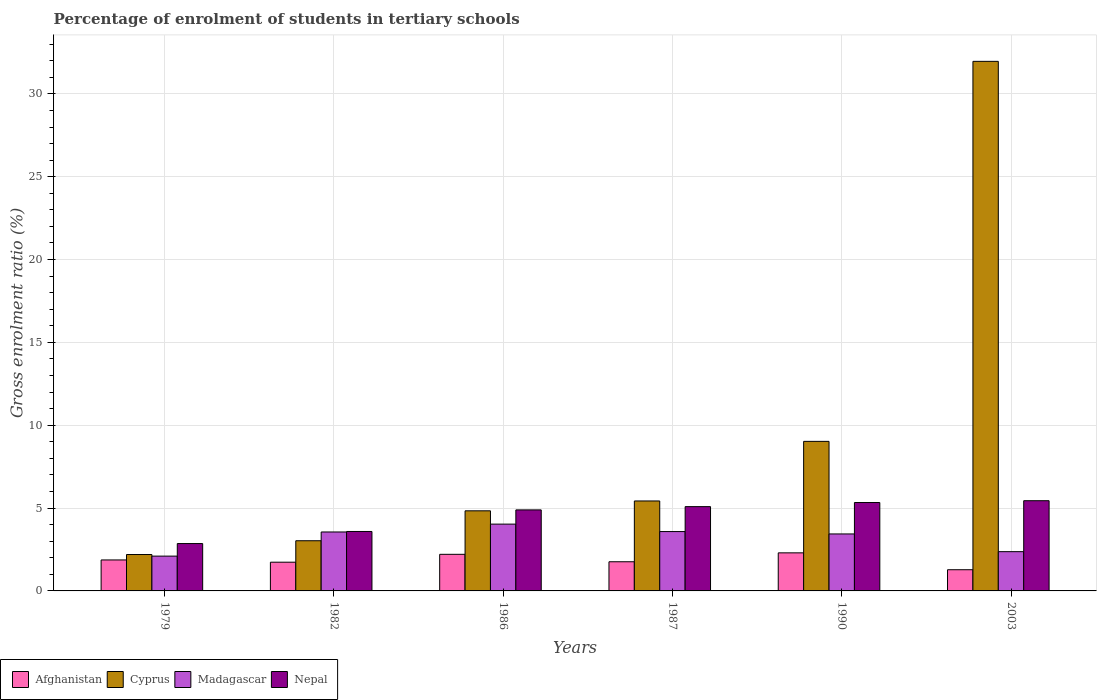How many different coloured bars are there?
Your answer should be very brief. 4. Are the number of bars per tick equal to the number of legend labels?
Your answer should be very brief. Yes. How many bars are there on the 5th tick from the right?
Keep it short and to the point. 4. What is the label of the 3rd group of bars from the left?
Give a very brief answer. 1986. In how many cases, is the number of bars for a given year not equal to the number of legend labels?
Provide a short and direct response. 0. What is the percentage of students enrolled in tertiary schools in Afghanistan in 1990?
Ensure brevity in your answer.  2.3. Across all years, what is the maximum percentage of students enrolled in tertiary schools in Madagascar?
Offer a terse response. 4.03. Across all years, what is the minimum percentage of students enrolled in tertiary schools in Cyprus?
Offer a very short reply. 2.2. In which year was the percentage of students enrolled in tertiary schools in Nepal maximum?
Provide a succinct answer. 2003. In which year was the percentage of students enrolled in tertiary schools in Nepal minimum?
Your answer should be compact. 1979. What is the total percentage of students enrolled in tertiary schools in Cyprus in the graph?
Make the answer very short. 56.48. What is the difference between the percentage of students enrolled in tertiary schools in Nepal in 1979 and that in 1987?
Your response must be concise. -2.23. What is the difference between the percentage of students enrolled in tertiary schools in Madagascar in 1986 and the percentage of students enrolled in tertiary schools in Afghanistan in 1982?
Give a very brief answer. 2.3. What is the average percentage of students enrolled in tertiary schools in Cyprus per year?
Offer a terse response. 9.41. In the year 1982, what is the difference between the percentage of students enrolled in tertiary schools in Afghanistan and percentage of students enrolled in tertiary schools in Cyprus?
Offer a terse response. -1.3. In how many years, is the percentage of students enrolled in tertiary schools in Nepal greater than 3 %?
Offer a very short reply. 5. What is the ratio of the percentage of students enrolled in tertiary schools in Madagascar in 1979 to that in 1982?
Offer a terse response. 0.59. Is the percentage of students enrolled in tertiary schools in Madagascar in 1986 less than that in 1987?
Provide a short and direct response. No. Is the difference between the percentage of students enrolled in tertiary schools in Afghanistan in 1990 and 2003 greater than the difference between the percentage of students enrolled in tertiary schools in Cyprus in 1990 and 2003?
Your answer should be very brief. Yes. What is the difference between the highest and the second highest percentage of students enrolled in tertiary schools in Afghanistan?
Provide a short and direct response. 0.09. What is the difference between the highest and the lowest percentage of students enrolled in tertiary schools in Afghanistan?
Keep it short and to the point. 1.02. In how many years, is the percentage of students enrolled in tertiary schools in Cyprus greater than the average percentage of students enrolled in tertiary schools in Cyprus taken over all years?
Your answer should be very brief. 1. What does the 1st bar from the left in 2003 represents?
Your response must be concise. Afghanistan. What does the 1st bar from the right in 1986 represents?
Provide a succinct answer. Nepal. Is it the case that in every year, the sum of the percentage of students enrolled in tertiary schools in Nepal and percentage of students enrolled in tertiary schools in Madagascar is greater than the percentage of students enrolled in tertiary schools in Cyprus?
Provide a short and direct response. No. Are all the bars in the graph horizontal?
Your response must be concise. No. How many years are there in the graph?
Ensure brevity in your answer.  6. What is the difference between two consecutive major ticks on the Y-axis?
Your response must be concise. 5. Does the graph contain grids?
Offer a very short reply. Yes. Where does the legend appear in the graph?
Your response must be concise. Bottom left. How many legend labels are there?
Provide a short and direct response. 4. How are the legend labels stacked?
Provide a short and direct response. Horizontal. What is the title of the graph?
Give a very brief answer. Percentage of enrolment of students in tertiary schools. Does "Uganda" appear as one of the legend labels in the graph?
Offer a terse response. No. What is the label or title of the X-axis?
Your answer should be very brief. Years. What is the label or title of the Y-axis?
Your answer should be very brief. Gross enrolment ratio (%). What is the Gross enrolment ratio (%) in Afghanistan in 1979?
Offer a terse response. 1.87. What is the Gross enrolment ratio (%) of Cyprus in 1979?
Offer a terse response. 2.2. What is the Gross enrolment ratio (%) of Madagascar in 1979?
Your answer should be compact. 2.1. What is the Gross enrolment ratio (%) in Nepal in 1979?
Your answer should be very brief. 2.86. What is the Gross enrolment ratio (%) in Afghanistan in 1982?
Ensure brevity in your answer.  1.73. What is the Gross enrolment ratio (%) of Cyprus in 1982?
Make the answer very short. 3.03. What is the Gross enrolment ratio (%) of Madagascar in 1982?
Offer a very short reply. 3.56. What is the Gross enrolment ratio (%) in Nepal in 1982?
Offer a very short reply. 3.59. What is the Gross enrolment ratio (%) of Afghanistan in 1986?
Provide a succinct answer. 2.21. What is the Gross enrolment ratio (%) in Cyprus in 1986?
Your answer should be very brief. 4.83. What is the Gross enrolment ratio (%) in Madagascar in 1986?
Your answer should be very brief. 4.03. What is the Gross enrolment ratio (%) of Nepal in 1986?
Your response must be concise. 4.89. What is the Gross enrolment ratio (%) in Afghanistan in 1987?
Ensure brevity in your answer.  1.76. What is the Gross enrolment ratio (%) of Cyprus in 1987?
Your answer should be compact. 5.43. What is the Gross enrolment ratio (%) in Madagascar in 1987?
Offer a very short reply. 3.58. What is the Gross enrolment ratio (%) of Nepal in 1987?
Your answer should be very brief. 5.09. What is the Gross enrolment ratio (%) in Afghanistan in 1990?
Make the answer very short. 2.3. What is the Gross enrolment ratio (%) of Cyprus in 1990?
Offer a terse response. 9.03. What is the Gross enrolment ratio (%) of Madagascar in 1990?
Provide a short and direct response. 3.44. What is the Gross enrolment ratio (%) in Nepal in 1990?
Make the answer very short. 5.34. What is the Gross enrolment ratio (%) of Afghanistan in 2003?
Provide a succinct answer. 1.28. What is the Gross enrolment ratio (%) of Cyprus in 2003?
Ensure brevity in your answer.  31.96. What is the Gross enrolment ratio (%) of Madagascar in 2003?
Provide a succinct answer. 2.37. What is the Gross enrolment ratio (%) in Nepal in 2003?
Provide a short and direct response. 5.44. Across all years, what is the maximum Gross enrolment ratio (%) of Afghanistan?
Your answer should be very brief. 2.3. Across all years, what is the maximum Gross enrolment ratio (%) in Cyprus?
Offer a terse response. 31.96. Across all years, what is the maximum Gross enrolment ratio (%) in Madagascar?
Your response must be concise. 4.03. Across all years, what is the maximum Gross enrolment ratio (%) in Nepal?
Your answer should be compact. 5.44. Across all years, what is the minimum Gross enrolment ratio (%) in Afghanistan?
Keep it short and to the point. 1.28. Across all years, what is the minimum Gross enrolment ratio (%) of Cyprus?
Make the answer very short. 2.2. Across all years, what is the minimum Gross enrolment ratio (%) in Madagascar?
Offer a terse response. 2.1. Across all years, what is the minimum Gross enrolment ratio (%) in Nepal?
Offer a very short reply. 2.86. What is the total Gross enrolment ratio (%) in Afghanistan in the graph?
Make the answer very short. 11.15. What is the total Gross enrolment ratio (%) in Cyprus in the graph?
Make the answer very short. 56.48. What is the total Gross enrolment ratio (%) of Madagascar in the graph?
Provide a short and direct response. 19.08. What is the total Gross enrolment ratio (%) in Nepal in the graph?
Offer a very short reply. 27.21. What is the difference between the Gross enrolment ratio (%) in Afghanistan in 1979 and that in 1982?
Offer a very short reply. 0.14. What is the difference between the Gross enrolment ratio (%) of Cyprus in 1979 and that in 1982?
Your answer should be very brief. -0.83. What is the difference between the Gross enrolment ratio (%) in Madagascar in 1979 and that in 1982?
Offer a terse response. -1.46. What is the difference between the Gross enrolment ratio (%) of Nepal in 1979 and that in 1982?
Offer a terse response. -0.73. What is the difference between the Gross enrolment ratio (%) of Afghanistan in 1979 and that in 1986?
Your answer should be very brief. -0.34. What is the difference between the Gross enrolment ratio (%) in Cyprus in 1979 and that in 1986?
Make the answer very short. -2.64. What is the difference between the Gross enrolment ratio (%) of Madagascar in 1979 and that in 1986?
Make the answer very short. -1.93. What is the difference between the Gross enrolment ratio (%) of Nepal in 1979 and that in 1986?
Your response must be concise. -2.03. What is the difference between the Gross enrolment ratio (%) in Afghanistan in 1979 and that in 1987?
Your answer should be compact. 0.11. What is the difference between the Gross enrolment ratio (%) of Cyprus in 1979 and that in 1987?
Provide a succinct answer. -3.23. What is the difference between the Gross enrolment ratio (%) of Madagascar in 1979 and that in 1987?
Provide a short and direct response. -1.48. What is the difference between the Gross enrolment ratio (%) of Nepal in 1979 and that in 1987?
Your answer should be very brief. -2.23. What is the difference between the Gross enrolment ratio (%) of Afghanistan in 1979 and that in 1990?
Your answer should be compact. -0.43. What is the difference between the Gross enrolment ratio (%) in Cyprus in 1979 and that in 1990?
Provide a short and direct response. -6.83. What is the difference between the Gross enrolment ratio (%) of Madagascar in 1979 and that in 1990?
Ensure brevity in your answer.  -1.34. What is the difference between the Gross enrolment ratio (%) of Nepal in 1979 and that in 1990?
Offer a terse response. -2.48. What is the difference between the Gross enrolment ratio (%) of Afghanistan in 1979 and that in 2003?
Offer a terse response. 0.59. What is the difference between the Gross enrolment ratio (%) of Cyprus in 1979 and that in 2003?
Keep it short and to the point. -29.77. What is the difference between the Gross enrolment ratio (%) in Madagascar in 1979 and that in 2003?
Give a very brief answer. -0.27. What is the difference between the Gross enrolment ratio (%) in Nepal in 1979 and that in 2003?
Keep it short and to the point. -2.59. What is the difference between the Gross enrolment ratio (%) in Afghanistan in 1982 and that in 1986?
Keep it short and to the point. -0.47. What is the difference between the Gross enrolment ratio (%) in Cyprus in 1982 and that in 1986?
Provide a succinct answer. -1.81. What is the difference between the Gross enrolment ratio (%) of Madagascar in 1982 and that in 1986?
Make the answer very short. -0.47. What is the difference between the Gross enrolment ratio (%) of Nepal in 1982 and that in 1986?
Offer a terse response. -1.3. What is the difference between the Gross enrolment ratio (%) of Afghanistan in 1982 and that in 1987?
Your response must be concise. -0.03. What is the difference between the Gross enrolment ratio (%) in Cyprus in 1982 and that in 1987?
Keep it short and to the point. -2.4. What is the difference between the Gross enrolment ratio (%) in Madagascar in 1982 and that in 1987?
Ensure brevity in your answer.  -0.02. What is the difference between the Gross enrolment ratio (%) of Nepal in 1982 and that in 1987?
Provide a succinct answer. -1.5. What is the difference between the Gross enrolment ratio (%) of Afghanistan in 1982 and that in 1990?
Make the answer very short. -0.56. What is the difference between the Gross enrolment ratio (%) of Cyprus in 1982 and that in 1990?
Your answer should be very brief. -6. What is the difference between the Gross enrolment ratio (%) of Madagascar in 1982 and that in 1990?
Keep it short and to the point. 0.12. What is the difference between the Gross enrolment ratio (%) of Nepal in 1982 and that in 1990?
Offer a terse response. -1.75. What is the difference between the Gross enrolment ratio (%) of Afghanistan in 1982 and that in 2003?
Provide a short and direct response. 0.45. What is the difference between the Gross enrolment ratio (%) in Cyprus in 1982 and that in 2003?
Your answer should be very brief. -28.93. What is the difference between the Gross enrolment ratio (%) in Madagascar in 1982 and that in 2003?
Offer a terse response. 1.19. What is the difference between the Gross enrolment ratio (%) in Nepal in 1982 and that in 2003?
Keep it short and to the point. -1.86. What is the difference between the Gross enrolment ratio (%) in Afghanistan in 1986 and that in 1987?
Give a very brief answer. 0.45. What is the difference between the Gross enrolment ratio (%) of Cyprus in 1986 and that in 1987?
Your answer should be very brief. -0.59. What is the difference between the Gross enrolment ratio (%) of Madagascar in 1986 and that in 1987?
Offer a terse response. 0.45. What is the difference between the Gross enrolment ratio (%) of Nepal in 1986 and that in 1987?
Your answer should be very brief. -0.2. What is the difference between the Gross enrolment ratio (%) of Afghanistan in 1986 and that in 1990?
Give a very brief answer. -0.09. What is the difference between the Gross enrolment ratio (%) in Cyprus in 1986 and that in 1990?
Provide a succinct answer. -4.19. What is the difference between the Gross enrolment ratio (%) of Madagascar in 1986 and that in 1990?
Your answer should be compact. 0.59. What is the difference between the Gross enrolment ratio (%) of Nepal in 1986 and that in 1990?
Keep it short and to the point. -0.44. What is the difference between the Gross enrolment ratio (%) of Afghanistan in 1986 and that in 2003?
Your answer should be very brief. 0.93. What is the difference between the Gross enrolment ratio (%) of Cyprus in 1986 and that in 2003?
Ensure brevity in your answer.  -27.13. What is the difference between the Gross enrolment ratio (%) of Madagascar in 1986 and that in 2003?
Give a very brief answer. 1.66. What is the difference between the Gross enrolment ratio (%) in Nepal in 1986 and that in 2003?
Offer a terse response. -0.55. What is the difference between the Gross enrolment ratio (%) in Afghanistan in 1987 and that in 1990?
Provide a succinct answer. -0.54. What is the difference between the Gross enrolment ratio (%) of Cyprus in 1987 and that in 1990?
Your response must be concise. -3.6. What is the difference between the Gross enrolment ratio (%) in Madagascar in 1987 and that in 1990?
Ensure brevity in your answer.  0.14. What is the difference between the Gross enrolment ratio (%) of Nepal in 1987 and that in 1990?
Offer a very short reply. -0.25. What is the difference between the Gross enrolment ratio (%) in Afghanistan in 1987 and that in 2003?
Provide a short and direct response. 0.48. What is the difference between the Gross enrolment ratio (%) in Cyprus in 1987 and that in 2003?
Keep it short and to the point. -26.53. What is the difference between the Gross enrolment ratio (%) of Madagascar in 1987 and that in 2003?
Offer a terse response. 1.21. What is the difference between the Gross enrolment ratio (%) of Nepal in 1987 and that in 2003?
Make the answer very short. -0.36. What is the difference between the Gross enrolment ratio (%) of Afghanistan in 1990 and that in 2003?
Your response must be concise. 1.02. What is the difference between the Gross enrolment ratio (%) in Cyprus in 1990 and that in 2003?
Keep it short and to the point. -22.94. What is the difference between the Gross enrolment ratio (%) in Madagascar in 1990 and that in 2003?
Provide a short and direct response. 1.07. What is the difference between the Gross enrolment ratio (%) of Nepal in 1990 and that in 2003?
Your response must be concise. -0.11. What is the difference between the Gross enrolment ratio (%) of Afghanistan in 1979 and the Gross enrolment ratio (%) of Cyprus in 1982?
Offer a terse response. -1.16. What is the difference between the Gross enrolment ratio (%) in Afghanistan in 1979 and the Gross enrolment ratio (%) in Madagascar in 1982?
Make the answer very short. -1.69. What is the difference between the Gross enrolment ratio (%) in Afghanistan in 1979 and the Gross enrolment ratio (%) in Nepal in 1982?
Make the answer very short. -1.72. What is the difference between the Gross enrolment ratio (%) in Cyprus in 1979 and the Gross enrolment ratio (%) in Madagascar in 1982?
Your answer should be very brief. -1.36. What is the difference between the Gross enrolment ratio (%) in Cyprus in 1979 and the Gross enrolment ratio (%) in Nepal in 1982?
Make the answer very short. -1.39. What is the difference between the Gross enrolment ratio (%) in Madagascar in 1979 and the Gross enrolment ratio (%) in Nepal in 1982?
Your answer should be compact. -1.49. What is the difference between the Gross enrolment ratio (%) in Afghanistan in 1979 and the Gross enrolment ratio (%) in Cyprus in 1986?
Your answer should be compact. -2.96. What is the difference between the Gross enrolment ratio (%) of Afghanistan in 1979 and the Gross enrolment ratio (%) of Madagascar in 1986?
Give a very brief answer. -2.16. What is the difference between the Gross enrolment ratio (%) of Afghanistan in 1979 and the Gross enrolment ratio (%) of Nepal in 1986?
Give a very brief answer. -3.02. What is the difference between the Gross enrolment ratio (%) of Cyprus in 1979 and the Gross enrolment ratio (%) of Madagascar in 1986?
Your answer should be very brief. -1.84. What is the difference between the Gross enrolment ratio (%) of Cyprus in 1979 and the Gross enrolment ratio (%) of Nepal in 1986?
Offer a terse response. -2.69. What is the difference between the Gross enrolment ratio (%) in Madagascar in 1979 and the Gross enrolment ratio (%) in Nepal in 1986?
Make the answer very short. -2.79. What is the difference between the Gross enrolment ratio (%) of Afghanistan in 1979 and the Gross enrolment ratio (%) of Cyprus in 1987?
Offer a very short reply. -3.56. What is the difference between the Gross enrolment ratio (%) in Afghanistan in 1979 and the Gross enrolment ratio (%) in Madagascar in 1987?
Your answer should be very brief. -1.71. What is the difference between the Gross enrolment ratio (%) in Afghanistan in 1979 and the Gross enrolment ratio (%) in Nepal in 1987?
Provide a succinct answer. -3.22. What is the difference between the Gross enrolment ratio (%) of Cyprus in 1979 and the Gross enrolment ratio (%) of Madagascar in 1987?
Offer a terse response. -1.39. What is the difference between the Gross enrolment ratio (%) of Cyprus in 1979 and the Gross enrolment ratio (%) of Nepal in 1987?
Offer a very short reply. -2.89. What is the difference between the Gross enrolment ratio (%) in Madagascar in 1979 and the Gross enrolment ratio (%) in Nepal in 1987?
Provide a short and direct response. -2.99. What is the difference between the Gross enrolment ratio (%) of Afghanistan in 1979 and the Gross enrolment ratio (%) of Cyprus in 1990?
Make the answer very short. -7.16. What is the difference between the Gross enrolment ratio (%) in Afghanistan in 1979 and the Gross enrolment ratio (%) in Madagascar in 1990?
Ensure brevity in your answer.  -1.57. What is the difference between the Gross enrolment ratio (%) of Afghanistan in 1979 and the Gross enrolment ratio (%) of Nepal in 1990?
Your answer should be compact. -3.47. What is the difference between the Gross enrolment ratio (%) in Cyprus in 1979 and the Gross enrolment ratio (%) in Madagascar in 1990?
Offer a terse response. -1.24. What is the difference between the Gross enrolment ratio (%) of Cyprus in 1979 and the Gross enrolment ratio (%) of Nepal in 1990?
Keep it short and to the point. -3.14. What is the difference between the Gross enrolment ratio (%) in Madagascar in 1979 and the Gross enrolment ratio (%) in Nepal in 1990?
Give a very brief answer. -3.23. What is the difference between the Gross enrolment ratio (%) of Afghanistan in 1979 and the Gross enrolment ratio (%) of Cyprus in 2003?
Ensure brevity in your answer.  -30.09. What is the difference between the Gross enrolment ratio (%) of Afghanistan in 1979 and the Gross enrolment ratio (%) of Madagascar in 2003?
Your answer should be very brief. -0.5. What is the difference between the Gross enrolment ratio (%) of Afghanistan in 1979 and the Gross enrolment ratio (%) of Nepal in 2003?
Keep it short and to the point. -3.57. What is the difference between the Gross enrolment ratio (%) in Cyprus in 1979 and the Gross enrolment ratio (%) in Madagascar in 2003?
Offer a terse response. -0.17. What is the difference between the Gross enrolment ratio (%) in Cyprus in 1979 and the Gross enrolment ratio (%) in Nepal in 2003?
Your answer should be compact. -3.25. What is the difference between the Gross enrolment ratio (%) of Madagascar in 1979 and the Gross enrolment ratio (%) of Nepal in 2003?
Make the answer very short. -3.34. What is the difference between the Gross enrolment ratio (%) in Afghanistan in 1982 and the Gross enrolment ratio (%) in Cyprus in 1986?
Your answer should be compact. -3.1. What is the difference between the Gross enrolment ratio (%) in Afghanistan in 1982 and the Gross enrolment ratio (%) in Madagascar in 1986?
Your answer should be very brief. -2.3. What is the difference between the Gross enrolment ratio (%) in Afghanistan in 1982 and the Gross enrolment ratio (%) in Nepal in 1986?
Provide a short and direct response. -3.16. What is the difference between the Gross enrolment ratio (%) in Cyprus in 1982 and the Gross enrolment ratio (%) in Madagascar in 1986?
Offer a terse response. -1. What is the difference between the Gross enrolment ratio (%) of Cyprus in 1982 and the Gross enrolment ratio (%) of Nepal in 1986?
Give a very brief answer. -1.86. What is the difference between the Gross enrolment ratio (%) of Madagascar in 1982 and the Gross enrolment ratio (%) of Nepal in 1986?
Your response must be concise. -1.33. What is the difference between the Gross enrolment ratio (%) in Afghanistan in 1982 and the Gross enrolment ratio (%) in Cyprus in 1987?
Offer a terse response. -3.7. What is the difference between the Gross enrolment ratio (%) of Afghanistan in 1982 and the Gross enrolment ratio (%) of Madagascar in 1987?
Offer a very short reply. -1.85. What is the difference between the Gross enrolment ratio (%) of Afghanistan in 1982 and the Gross enrolment ratio (%) of Nepal in 1987?
Your answer should be very brief. -3.35. What is the difference between the Gross enrolment ratio (%) in Cyprus in 1982 and the Gross enrolment ratio (%) in Madagascar in 1987?
Provide a short and direct response. -0.55. What is the difference between the Gross enrolment ratio (%) in Cyprus in 1982 and the Gross enrolment ratio (%) in Nepal in 1987?
Provide a succinct answer. -2.06. What is the difference between the Gross enrolment ratio (%) of Madagascar in 1982 and the Gross enrolment ratio (%) of Nepal in 1987?
Your response must be concise. -1.53. What is the difference between the Gross enrolment ratio (%) of Afghanistan in 1982 and the Gross enrolment ratio (%) of Cyprus in 1990?
Keep it short and to the point. -7.29. What is the difference between the Gross enrolment ratio (%) of Afghanistan in 1982 and the Gross enrolment ratio (%) of Madagascar in 1990?
Provide a short and direct response. -1.7. What is the difference between the Gross enrolment ratio (%) in Afghanistan in 1982 and the Gross enrolment ratio (%) in Nepal in 1990?
Ensure brevity in your answer.  -3.6. What is the difference between the Gross enrolment ratio (%) in Cyprus in 1982 and the Gross enrolment ratio (%) in Madagascar in 1990?
Provide a short and direct response. -0.41. What is the difference between the Gross enrolment ratio (%) of Cyprus in 1982 and the Gross enrolment ratio (%) of Nepal in 1990?
Your response must be concise. -2.31. What is the difference between the Gross enrolment ratio (%) of Madagascar in 1982 and the Gross enrolment ratio (%) of Nepal in 1990?
Offer a very short reply. -1.78. What is the difference between the Gross enrolment ratio (%) in Afghanistan in 1982 and the Gross enrolment ratio (%) in Cyprus in 2003?
Give a very brief answer. -30.23. What is the difference between the Gross enrolment ratio (%) of Afghanistan in 1982 and the Gross enrolment ratio (%) of Madagascar in 2003?
Provide a succinct answer. -0.64. What is the difference between the Gross enrolment ratio (%) in Afghanistan in 1982 and the Gross enrolment ratio (%) in Nepal in 2003?
Ensure brevity in your answer.  -3.71. What is the difference between the Gross enrolment ratio (%) in Cyprus in 1982 and the Gross enrolment ratio (%) in Madagascar in 2003?
Offer a very short reply. 0.66. What is the difference between the Gross enrolment ratio (%) of Cyprus in 1982 and the Gross enrolment ratio (%) of Nepal in 2003?
Offer a very short reply. -2.42. What is the difference between the Gross enrolment ratio (%) in Madagascar in 1982 and the Gross enrolment ratio (%) in Nepal in 2003?
Provide a succinct answer. -1.89. What is the difference between the Gross enrolment ratio (%) in Afghanistan in 1986 and the Gross enrolment ratio (%) in Cyprus in 1987?
Your answer should be very brief. -3.22. What is the difference between the Gross enrolment ratio (%) in Afghanistan in 1986 and the Gross enrolment ratio (%) in Madagascar in 1987?
Give a very brief answer. -1.37. What is the difference between the Gross enrolment ratio (%) in Afghanistan in 1986 and the Gross enrolment ratio (%) in Nepal in 1987?
Provide a short and direct response. -2.88. What is the difference between the Gross enrolment ratio (%) in Cyprus in 1986 and the Gross enrolment ratio (%) in Madagascar in 1987?
Your answer should be compact. 1.25. What is the difference between the Gross enrolment ratio (%) in Cyprus in 1986 and the Gross enrolment ratio (%) in Nepal in 1987?
Your answer should be compact. -0.25. What is the difference between the Gross enrolment ratio (%) in Madagascar in 1986 and the Gross enrolment ratio (%) in Nepal in 1987?
Keep it short and to the point. -1.06. What is the difference between the Gross enrolment ratio (%) in Afghanistan in 1986 and the Gross enrolment ratio (%) in Cyprus in 1990?
Provide a succinct answer. -6.82. What is the difference between the Gross enrolment ratio (%) of Afghanistan in 1986 and the Gross enrolment ratio (%) of Madagascar in 1990?
Keep it short and to the point. -1.23. What is the difference between the Gross enrolment ratio (%) of Afghanistan in 1986 and the Gross enrolment ratio (%) of Nepal in 1990?
Make the answer very short. -3.13. What is the difference between the Gross enrolment ratio (%) of Cyprus in 1986 and the Gross enrolment ratio (%) of Madagascar in 1990?
Ensure brevity in your answer.  1.4. What is the difference between the Gross enrolment ratio (%) in Cyprus in 1986 and the Gross enrolment ratio (%) in Nepal in 1990?
Offer a terse response. -0.5. What is the difference between the Gross enrolment ratio (%) of Madagascar in 1986 and the Gross enrolment ratio (%) of Nepal in 1990?
Make the answer very short. -1.3. What is the difference between the Gross enrolment ratio (%) of Afghanistan in 1986 and the Gross enrolment ratio (%) of Cyprus in 2003?
Ensure brevity in your answer.  -29.75. What is the difference between the Gross enrolment ratio (%) of Afghanistan in 1986 and the Gross enrolment ratio (%) of Madagascar in 2003?
Your response must be concise. -0.16. What is the difference between the Gross enrolment ratio (%) in Afghanistan in 1986 and the Gross enrolment ratio (%) in Nepal in 2003?
Your response must be concise. -3.24. What is the difference between the Gross enrolment ratio (%) of Cyprus in 1986 and the Gross enrolment ratio (%) of Madagascar in 2003?
Provide a succinct answer. 2.47. What is the difference between the Gross enrolment ratio (%) of Cyprus in 1986 and the Gross enrolment ratio (%) of Nepal in 2003?
Your response must be concise. -0.61. What is the difference between the Gross enrolment ratio (%) in Madagascar in 1986 and the Gross enrolment ratio (%) in Nepal in 2003?
Give a very brief answer. -1.41. What is the difference between the Gross enrolment ratio (%) of Afghanistan in 1987 and the Gross enrolment ratio (%) of Cyprus in 1990?
Make the answer very short. -7.27. What is the difference between the Gross enrolment ratio (%) of Afghanistan in 1987 and the Gross enrolment ratio (%) of Madagascar in 1990?
Provide a short and direct response. -1.68. What is the difference between the Gross enrolment ratio (%) of Afghanistan in 1987 and the Gross enrolment ratio (%) of Nepal in 1990?
Your response must be concise. -3.58. What is the difference between the Gross enrolment ratio (%) in Cyprus in 1987 and the Gross enrolment ratio (%) in Madagascar in 1990?
Keep it short and to the point. 1.99. What is the difference between the Gross enrolment ratio (%) in Cyprus in 1987 and the Gross enrolment ratio (%) in Nepal in 1990?
Provide a succinct answer. 0.09. What is the difference between the Gross enrolment ratio (%) of Madagascar in 1987 and the Gross enrolment ratio (%) of Nepal in 1990?
Provide a succinct answer. -1.75. What is the difference between the Gross enrolment ratio (%) in Afghanistan in 1987 and the Gross enrolment ratio (%) in Cyprus in 2003?
Ensure brevity in your answer.  -30.2. What is the difference between the Gross enrolment ratio (%) in Afghanistan in 1987 and the Gross enrolment ratio (%) in Madagascar in 2003?
Provide a succinct answer. -0.61. What is the difference between the Gross enrolment ratio (%) of Afghanistan in 1987 and the Gross enrolment ratio (%) of Nepal in 2003?
Make the answer very short. -3.69. What is the difference between the Gross enrolment ratio (%) in Cyprus in 1987 and the Gross enrolment ratio (%) in Madagascar in 2003?
Provide a succinct answer. 3.06. What is the difference between the Gross enrolment ratio (%) of Cyprus in 1987 and the Gross enrolment ratio (%) of Nepal in 2003?
Give a very brief answer. -0.02. What is the difference between the Gross enrolment ratio (%) of Madagascar in 1987 and the Gross enrolment ratio (%) of Nepal in 2003?
Keep it short and to the point. -1.86. What is the difference between the Gross enrolment ratio (%) of Afghanistan in 1990 and the Gross enrolment ratio (%) of Cyprus in 2003?
Your response must be concise. -29.67. What is the difference between the Gross enrolment ratio (%) in Afghanistan in 1990 and the Gross enrolment ratio (%) in Madagascar in 2003?
Make the answer very short. -0.07. What is the difference between the Gross enrolment ratio (%) of Afghanistan in 1990 and the Gross enrolment ratio (%) of Nepal in 2003?
Your answer should be very brief. -3.15. What is the difference between the Gross enrolment ratio (%) in Cyprus in 1990 and the Gross enrolment ratio (%) in Madagascar in 2003?
Give a very brief answer. 6.66. What is the difference between the Gross enrolment ratio (%) of Cyprus in 1990 and the Gross enrolment ratio (%) of Nepal in 2003?
Your answer should be compact. 3.58. What is the difference between the Gross enrolment ratio (%) of Madagascar in 1990 and the Gross enrolment ratio (%) of Nepal in 2003?
Your answer should be very brief. -2.01. What is the average Gross enrolment ratio (%) of Afghanistan per year?
Your answer should be compact. 1.86. What is the average Gross enrolment ratio (%) in Cyprus per year?
Your answer should be very brief. 9.41. What is the average Gross enrolment ratio (%) of Madagascar per year?
Give a very brief answer. 3.18. What is the average Gross enrolment ratio (%) in Nepal per year?
Offer a terse response. 4.53. In the year 1979, what is the difference between the Gross enrolment ratio (%) in Afghanistan and Gross enrolment ratio (%) in Cyprus?
Offer a terse response. -0.33. In the year 1979, what is the difference between the Gross enrolment ratio (%) of Afghanistan and Gross enrolment ratio (%) of Madagascar?
Your answer should be very brief. -0.23. In the year 1979, what is the difference between the Gross enrolment ratio (%) of Afghanistan and Gross enrolment ratio (%) of Nepal?
Ensure brevity in your answer.  -0.99. In the year 1979, what is the difference between the Gross enrolment ratio (%) in Cyprus and Gross enrolment ratio (%) in Madagascar?
Offer a very short reply. 0.1. In the year 1979, what is the difference between the Gross enrolment ratio (%) in Cyprus and Gross enrolment ratio (%) in Nepal?
Offer a very short reply. -0.66. In the year 1979, what is the difference between the Gross enrolment ratio (%) of Madagascar and Gross enrolment ratio (%) of Nepal?
Offer a very short reply. -0.76. In the year 1982, what is the difference between the Gross enrolment ratio (%) in Afghanistan and Gross enrolment ratio (%) in Cyprus?
Your response must be concise. -1.3. In the year 1982, what is the difference between the Gross enrolment ratio (%) of Afghanistan and Gross enrolment ratio (%) of Madagascar?
Make the answer very short. -1.82. In the year 1982, what is the difference between the Gross enrolment ratio (%) of Afghanistan and Gross enrolment ratio (%) of Nepal?
Offer a very short reply. -1.85. In the year 1982, what is the difference between the Gross enrolment ratio (%) of Cyprus and Gross enrolment ratio (%) of Madagascar?
Ensure brevity in your answer.  -0.53. In the year 1982, what is the difference between the Gross enrolment ratio (%) in Cyprus and Gross enrolment ratio (%) in Nepal?
Your response must be concise. -0.56. In the year 1982, what is the difference between the Gross enrolment ratio (%) in Madagascar and Gross enrolment ratio (%) in Nepal?
Your answer should be very brief. -0.03. In the year 1986, what is the difference between the Gross enrolment ratio (%) in Afghanistan and Gross enrolment ratio (%) in Cyprus?
Ensure brevity in your answer.  -2.63. In the year 1986, what is the difference between the Gross enrolment ratio (%) of Afghanistan and Gross enrolment ratio (%) of Madagascar?
Keep it short and to the point. -1.82. In the year 1986, what is the difference between the Gross enrolment ratio (%) in Afghanistan and Gross enrolment ratio (%) in Nepal?
Your answer should be very brief. -2.68. In the year 1986, what is the difference between the Gross enrolment ratio (%) of Cyprus and Gross enrolment ratio (%) of Madagascar?
Provide a short and direct response. 0.8. In the year 1986, what is the difference between the Gross enrolment ratio (%) of Cyprus and Gross enrolment ratio (%) of Nepal?
Offer a terse response. -0.06. In the year 1986, what is the difference between the Gross enrolment ratio (%) of Madagascar and Gross enrolment ratio (%) of Nepal?
Offer a very short reply. -0.86. In the year 1987, what is the difference between the Gross enrolment ratio (%) in Afghanistan and Gross enrolment ratio (%) in Cyprus?
Ensure brevity in your answer.  -3.67. In the year 1987, what is the difference between the Gross enrolment ratio (%) of Afghanistan and Gross enrolment ratio (%) of Madagascar?
Offer a very short reply. -1.82. In the year 1987, what is the difference between the Gross enrolment ratio (%) of Afghanistan and Gross enrolment ratio (%) of Nepal?
Ensure brevity in your answer.  -3.33. In the year 1987, what is the difference between the Gross enrolment ratio (%) in Cyprus and Gross enrolment ratio (%) in Madagascar?
Keep it short and to the point. 1.85. In the year 1987, what is the difference between the Gross enrolment ratio (%) in Cyprus and Gross enrolment ratio (%) in Nepal?
Provide a succinct answer. 0.34. In the year 1987, what is the difference between the Gross enrolment ratio (%) of Madagascar and Gross enrolment ratio (%) of Nepal?
Make the answer very short. -1.51. In the year 1990, what is the difference between the Gross enrolment ratio (%) in Afghanistan and Gross enrolment ratio (%) in Cyprus?
Provide a short and direct response. -6.73. In the year 1990, what is the difference between the Gross enrolment ratio (%) in Afghanistan and Gross enrolment ratio (%) in Madagascar?
Give a very brief answer. -1.14. In the year 1990, what is the difference between the Gross enrolment ratio (%) of Afghanistan and Gross enrolment ratio (%) of Nepal?
Keep it short and to the point. -3.04. In the year 1990, what is the difference between the Gross enrolment ratio (%) in Cyprus and Gross enrolment ratio (%) in Madagascar?
Offer a very short reply. 5.59. In the year 1990, what is the difference between the Gross enrolment ratio (%) of Cyprus and Gross enrolment ratio (%) of Nepal?
Offer a very short reply. 3.69. In the year 1990, what is the difference between the Gross enrolment ratio (%) in Madagascar and Gross enrolment ratio (%) in Nepal?
Give a very brief answer. -1.9. In the year 2003, what is the difference between the Gross enrolment ratio (%) in Afghanistan and Gross enrolment ratio (%) in Cyprus?
Provide a short and direct response. -30.68. In the year 2003, what is the difference between the Gross enrolment ratio (%) in Afghanistan and Gross enrolment ratio (%) in Madagascar?
Your answer should be compact. -1.09. In the year 2003, what is the difference between the Gross enrolment ratio (%) of Afghanistan and Gross enrolment ratio (%) of Nepal?
Offer a terse response. -4.17. In the year 2003, what is the difference between the Gross enrolment ratio (%) of Cyprus and Gross enrolment ratio (%) of Madagascar?
Offer a very short reply. 29.59. In the year 2003, what is the difference between the Gross enrolment ratio (%) in Cyprus and Gross enrolment ratio (%) in Nepal?
Offer a very short reply. 26.52. In the year 2003, what is the difference between the Gross enrolment ratio (%) in Madagascar and Gross enrolment ratio (%) in Nepal?
Keep it short and to the point. -3.08. What is the ratio of the Gross enrolment ratio (%) in Afghanistan in 1979 to that in 1982?
Provide a short and direct response. 1.08. What is the ratio of the Gross enrolment ratio (%) of Cyprus in 1979 to that in 1982?
Give a very brief answer. 0.73. What is the ratio of the Gross enrolment ratio (%) in Madagascar in 1979 to that in 1982?
Your response must be concise. 0.59. What is the ratio of the Gross enrolment ratio (%) in Nepal in 1979 to that in 1982?
Your response must be concise. 0.8. What is the ratio of the Gross enrolment ratio (%) of Afghanistan in 1979 to that in 1986?
Your answer should be very brief. 0.85. What is the ratio of the Gross enrolment ratio (%) in Cyprus in 1979 to that in 1986?
Ensure brevity in your answer.  0.45. What is the ratio of the Gross enrolment ratio (%) of Madagascar in 1979 to that in 1986?
Your answer should be compact. 0.52. What is the ratio of the Gross enrolment ratio (%) of Nepal in 1979 to that in 1986?
Provide a succinct answer. 0.58. What is the ratio of the Gross enrolment ratio (%) of Afghanistan in 1979 to that in 1987?
Provide a succinct answer. 1.06. What is the ratio of the Gross enrolment ratio (%) of Cyprus in 1979 to that in 1987?
Provide a succinct answer. 0.4. What is the ratio of the Gross enrolment ratio (%) of Madagascar in 1979 to that in 1987?
Your answer should be very brief. 0.59. What is the ratio of the Gross enrolment ratio (%) of Nepal in 1979 to that in 1987?
Provide a short and direct response. 0.56. What is the ratio of the Gross enrolment ratio (%) of Afghanistan in 1979 to that in 1990?
Offer a very short reply. 0.81. What is the ratio of the Gross enrolment ratio (%) of Cyprus in 1979 to that in 1990?
Ensure brevity in your answer.  0.24. What is the ratio of the Gross enrolment ratio (%) of Madagascar in 1979 to that in 1990?
Your answer should be compact. 0.61. What is the ratio of the Gross enrolment ratio (%) of Nepal in 1979 to that in 1990?
Your answer should be very brief. 0.54. What is the ratio of the Gross enrolment ratio (%) in Afghanistan in 1979 to that in 2003?
Provide a short and direct response. 1.46. What is the ratio of the Gross enrolment ratio (%) in Cyprus in 1979 to that in 2003?
Provide a short and direct response. 0.07. What is the ratio of the Gross enrolment ratio (%) of Madagascar in 1979 to that in 2003?
Make the answer very short. 0.89. What is the ratio of the Gross enrolment ratio (%) in Nepal in 1979 to that in 2003?
Your answer should be very brief. 0.53. What is the ratio of the Gross enrolment ratio (%) of Afghanistan in 1982 to that in 1986?
Offer a terse response. 0.78. What is the ratio of the Gross enrolment ratio (%) in Cyprus in 1982 to that in 1986?
Offer a very short reply. 0.63. What is the ratio of the Gross enrolment ratio (%) of Madagascar in 1982 to that in 1986?
Make the answer very short. 0.88. What is the ratio of the Gross enrolment ratio (%) of Nepal in 1982 to that in 1986?
Your response must be concise. 0.73. What is the ratio of the Gross enrolment ratio (%) of Afghanistan in 1982 to that in 1987?
Your answer should be compact. 0.99. What is the ratio of the Gross enrolment ratio (%) of Cyprus in 1982 to that in 1987?
Make the answer very short. 0.56. What is the ratio of the Gross enrolment ratio (%) in Nepal in 1982 to that in 1987?
Your answer should be very brief. 0.71. What is the ratio of the Gross enrolment ratio (%) in Afghanistan in 1982 to that in 1990?
Your answer should be compact. 0.75. What is the ratio of the Gross enrolment ratio (%) of Cyprus in 1982 to that in 1990?
Provide a short and direct response. 0.34. What is the ratio of the Gross enrolment ratio (%) in Madagascar in 1982 to that in 1990?
Offer a terse response. 1.03. What is the ratio of the Gross enrolment ratio (%) of Nepal in 1982 to that in 1990?
Your answer should be very brief. 0.67. What is the ratio of the Gross enrolment ratio (%) in Afghanistan in 1982 to that in 2003?
Your response must be concise. 1.36. What is the ratio of the Gross enrolment ratio (%) of Cyprus in 1982 to that in 2003?
Keep it short and to the point. 0.09. What is the ratio of the Gross enrolment ratio (%) of Madagascar in 1982 to that in 2003?
Offer a terse response. 1.5. What is the ratio of the Gross enrolment ratio (%) in Nepal in 1982 to that in 2003?
Provide a short and direct response. 0.66. What is the ratio of the Gross enrolment ratio (%) of Afghanistan in 1986 to that in 1987?
Make the answer very short. 1.26. What is the ratio of the Gross enrolment ratio (%) of Cyprus in 1986 to that in 1987?
Give a very brief answer. 0.89. What is the ratio of the Gross enrolment ratio (%) in Madagascar in 1986 to that in 1987?
Your answer should be very brief. 1.13. What is the ratio of the Gross enrolment ratio (%) in Nepal in 1986 to that in 1987?
Your answer should be very brief. 0.96. What is the ratio of the Gross enrolment ratio (%) of Afghanistan in 1986 to that in 1990?
Your answer should be very brief. 0.96. What is the ratio of the Gross enrolment ratio (%) of Cyprus in 1986 to that in 1990?
Provide a short and direct response. 0.54. What is the ratio of the Gross enrolment ratio (%) of Madagascar in 1986 to that in 1990?
Give a very brief answer. 1.17. What is the ratio of the Gross enrolment ratio (%) in Afghanistan in 1986 to that in 2003?
Keep it short and to the point. 1.73. What is the ratio of the Gross enrolment ratio (%) in Cyprus in 1986 to that in 2003?
Provide a succinct answer. 0.15. What is the ratio of the Gross enrolment ratio (%) in Madagascar in 1986 to that in 2003?
Provide a short and direct response. 1.7. What is the ratio of the Gross enrolment ratio (%) of Nepal in 1986 to that in 2003?
Provide a succinct answer. 0.9. What is the ratio of the Gross enrolment ratio (%) of Afghanistan in 1987 to that in 1990?
Offer a very short reply. 0.77. What is the ratio of the Gross enrolment ratio (%) of Cyprus in 1987 to that in 1990?
Ensure brevity in your answer.  0.6. What is the ratio of the Gross enrolment ratio (%) in Madagascar in 1987 to that in 1990?
Give a very brief answer. 1.04. What is the ratio of the Gross enrolment ratio (%) of Nepal in 1987 to that in 1990?
Offer a very short reply. 0.95. What is the ratio of the Gross enrolment ratio (%) of Afghanistan in 1987 to that in 2003?
Provide a succinct answer. 1.38. What is the ratio of the Gross enrolment ratio (%) in Cyprus in 1987 to that in 2003?
Provide a succinct answer. 0.17. What is the ratio of the Gross enrolment ratio (%) of Madagascar in 1987 to that in 2003?
Give a very brief answer. 1.51. What is the ratio of the Gross enrolment ratio (%) in Nepal in 1987 to that in 2003?
Your answer should be compact. 0.93. What is the ratio of the Gross enrolment ratio (%) in Afghanistan in 1990 to that in 2003?
Give a very brief answer. 1.8. What is the ratio of the Gross enrolment ratio (%) in Cyprus in 1990 to that in 2003?
Your response must be concise. 0.28. What is the ratio of the Gross enrolment ratio (%) in Madagascar in 1990 to that in 2003?
Give a very brief answer. 1.45. What is the ratio of the Gross enrolment ratio (%) of Nepal in 1990 to that in 2003?
Make the answer very short. 0.98. What is the difference between the highest and the second highest Gross enrolment ratio (%) in Afghanistan?
Provide a succinct answer. 0.09. What is the difference between the highest and the second highest Gross enrolment ratio (%) in Cyprus?
Your answer should be very brief. 22.94. What is the difference between the highest and the second highest Gross enrolment ratio (%) in Madagascar?
Offer a terse response. 0.45. What is the difference between the highest and the second highest Gross enrolment ratio (%) in Nepal?
Your response must be concise. 0.11. What is the difference between the highest and the lowest Gross enrolment ratio (%) of Cyprus?
Ensure brevity in your answer.  29.77. What is the difference between the highest and the lowest Gross enrolment ratio (%) in Madagascar?
Your response must be concise. 1.93. What is the difference between the highest and the lowest Gross enrolment ratio (%) in Nepal?
Keep it short and to the point. 2.59. 